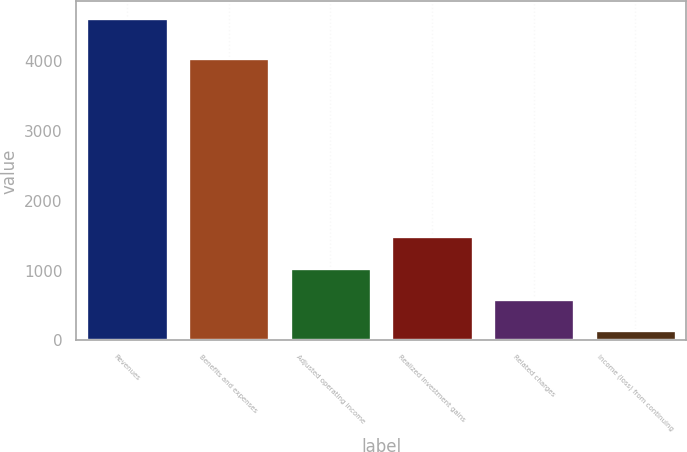Convert chart to OTSL. <chart><loc_0><loc_0><loc_500><loc_500><bar_chart><fcel>Revenues<fcel>Benefits and expenses<fcel>Adjusted operating income<fcel>Realized investment gains<fcel>Related charges<fcel>Income (loss) from continuing<nl><fcel>4620<fcel>4037<fcel>1040<fcel>1487.5<fcel>592.5<fcel>145<nl></chart> 